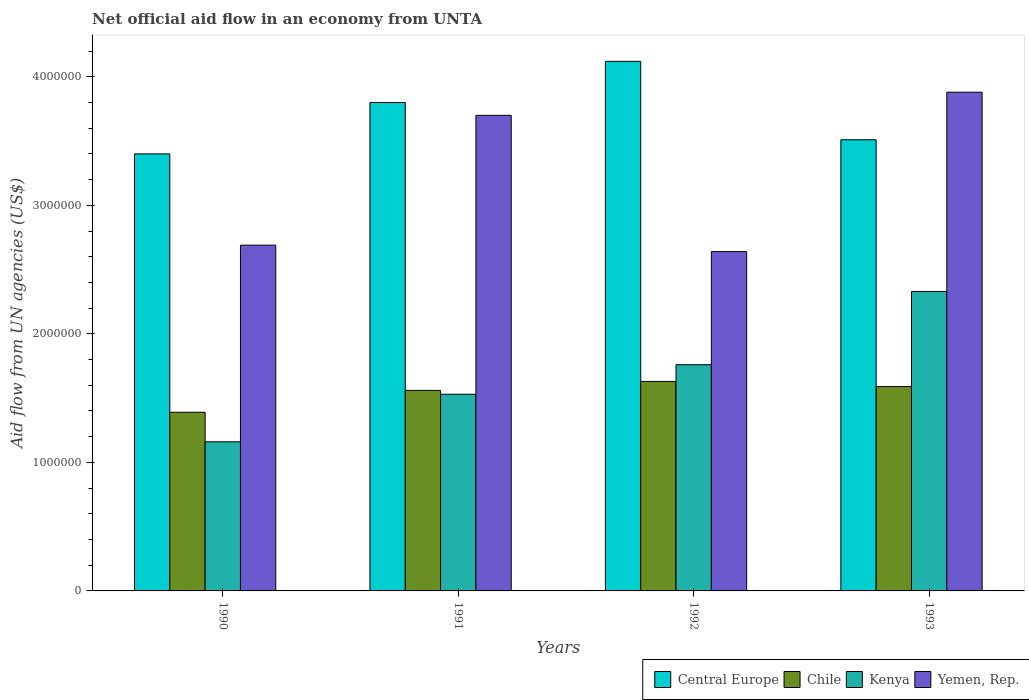How many groups of bars are there?
Make the answer very short. 4. Are the number of bars per tick equal to the number of legend labels?
Make the answer very short. Yes. How many bars are there on the 1st tick from the left?
Give a very brief answer. 4. What is the label of the 2nd group of bars from the left?
Your answer should be compact. 1991. In how many cases, is the number of bars for a given year not equal to the number of legend labels?
Provide a short and direct response. 0. What is the net official aid flow in Kenya in 1992?
Make the answer very short. 1.76e+06. Across all years, what is the maximum net official aid flow in Central Europe?
Provide a succinct answer. 4.12e+06. Across all years, what is the minimum net official aid flow in Kenya?
Your answer should be very brief. 1.16e+06. What is the total net official aid flow in Yemen, Rep. in the graph?
Ensure brevity in your answer.  1.29e+07. What is the difference between the net official aid flow in Chile in 1993 and the net official aid flow in Central Europe in 1990?
Ensure brevity in your answer.  -1.81e+06. What is the average net official aid flow in Yemen, Rep. per year?
Provide a short and direct response. 3.23e+06. In the year 1992, what is the difference between the net official aid flow in Yemen, Rep. and net official aid flow in Chile?
Your response must be concise. 1.01e+06. In how many years, is the net official aid flow in Kenya greater than 2800000 US$?
Give a very brief answer. 0. What is the ratio of the net official aid flow in Chile in 1990 to that in 1993?
Ensure brevity in your answer.  0.87. Is the net official aid flow in Central Europe in 1990 less than that in 1992?
Your answer should be compact. Yes. Is the difference between the net official aid flow in Yemen, Rep. in 1990 and 1993 greater than the difference between the net official aid flow in Chile in 1990 and 1993?
Provide a succinct answer. No. What is the difference between the highest and the second highest net official aid flow in Central Europe?
Provide a succinct answer. 3.20e+05. What is the difference between the highest and the lowest net official aid flow in Central Europe?
Provide a succinct answer. 7.20e+05. Is the sum of the net official aid flow in Chile in 1991 and 1993 greater than the maximum net official aid flow in Yemen, Rep. across all years?
Offer a terse response. No. Is it the case that in every year, the sum of the net official aid flow in Kenya and net official aid flow in Central Europe is greater than the sum of net official aid flow in Yemen, Rep. and net official aid flow in Chile?
Ensure brevity in your answer.  Yes. What does the 3rd bar from the left in 1993 represents?
Keep it short and to the point. Kenya. What does the 4th bar from the right in 1991 represents?
Your answer should be very brief. Central Europe. Are all the bars in the graph horizontal?
Your answer should be very brief. No. How many years are there in the graph?
Your answer should be compact. 4. What is the difference between two consecutive major ticks on the Y-axis?
Keep it short and to the point. 1.00e+06. Does the graph contain any zero values?
Give a very brief answer. No. Does the graph contain grids?
Your response must be concise. No. Where does the legend appear in the graph?
Ensure brevity in your answer.  Bottom right. What is the title of the graph?
Your answer should be compact. Net official aid flow in an economy from UNTA. What is the label or title of the Y-axis?
Offer a terse response. Aid flow from UN agencies (US$). What is the Aid flow from UN agencies (US$) in Central Europe in 1990?
Your response must be concise. 3.40e+06. What is the Aid flow from UN agencies (US$) of Chile in 1990?
Make the answer very short. 1.39e+06. What is the Aid flow from UN agencies (US$) of Kenya in 1990?
Make the answer very short. 1.16e+06. What is the Aid flow from UN agencies (US$) in Yemen, Rep. in 1990?
Your answer should be very brief. 2.69e+06. What is the Aid flow from UN agencies (US$) of Central Europe in 1991?
Provide a short and direct response. 3.80e+06. What is the Aid flow from UN agencies (US$) of Chile in 1991?
Your answer should be very brief. 1.56e+06. What is the Aid flow from UN agencies (US$) of Kenya in 1991?
Ensure brevity in your answer.  1.53e+06. What is the Aid flow from UN agencies (US$) in Yemen, Rep. in 1991?
Keep it short and to the point. 3.70e+06. What is the Aid flow from UN agencies (US$) in Central Europe in 1992?
Your answer should be compact. 4.12e+06. What is the Aid flow from UN agencies (US$) in Chile in 1992?
Your answer should be compact. 1.63e+06. What is the Aid flow from UN agencies (US$) of Kenya in 1992?
Keep it short and to the point. 1.76e+06. What is the Aid flow from UN agencies (US$) of Yemen, Rep. in 1992?
Your answer should be very brief. 2.64e+06. What is the Aid flow from UN agencies (US$) of Central Europe in 1993?
Ensure brevity in your answer.  3.51e+06. What is the Aid flow from UN agencies (US$) in Chile in 1993?
Your answer should be compact. 1.59e+06. What is the Aid flow from UN agencies (US$) of Kenya in 1993?
Make the answer very short. 2.33e+06. What is the Aid flow from UN agencies (US$) of Yemen, Rep. in 1993?
Provide a short and direct response. 3.88e+06. Across all years, what is the maximum Aid flow from UN agencies (US$) of Central Europe?
Offer a very short reply. 4.12e+06. Across all years, what is the maximum Aid flow from UN agencies (US$) of Chile?
Give a very brief answer. 1.63e+06. Across all years, what is the maximum Aid flow from UN agencies (US$) of Kenya?
Offer a terse response. 2.33e+06. Across all years, what is the maximum Aid flow from UN agencies (US$) in Yemen, Rep.?
Your answer should be very brief. 3.88e+06. Across all years, what is the minimum Aid flow from UN agencies (US$) in Central Europe?
Provide a succinct answer. 3.40e+06. Across all years, what is the minimum Aid flow from UN agencies (US$) of Chile?
Provide a succinct answer. 1.39e+06. Across all years, what is the minimum Aid flow from UN agencies (US$) in Kenya?
Your answer should be very brief. 1.16e+06. Across all years, what is the minimum Aid flow from UN agencies (US$) of Yemen, Rep.?
Provide a short and direct response. 2.64e+06. What is the total Aid flow from UN agencies (US$) in Central Europe in the graph?
Provide a short and direct response. 1.48e+07. What is the total Aid flow from UN agencies (US$) in Chile in the graph?
Make the answer very short. 6.17e+06. What is the total Aid flow from UN agencies (US$) of Kenya in the graph?
Keep it short and to the point. 6.78e+06. What is the total Aid flow from UN agencies (US$) in Yemen, Rep. in the graph?
Give a very brief answer. 1.29e+07. What is the difference between the Aid flow from UN agencies (US$) in Central Europe in 1990 and that in 1991?
Your response must be concise. -4.00e+05. What is the difference between the Aid flow from UN agencies (US$) of Kenya in 1990 and that in 1991?
Your response must be concise. -3.70e+05. What is the difference between the Aid flow from UN agencies (US$) in Yemen, Rep. in 1990 and that in 1991?
Keep it short and to the point. -1.01e+06. What is the difference between the Aid flow from UN agencies (US$) of Central Europe in 1990 and that in 1992?
Offer a terse response. -7.20e+05. What is the difference between the Aid flow from UN agencies (US$) in Kenya in 1990 and that in 1992?
Provide a short and direct response. -6.00e+05. What is the difference between the Aid flow from UN agencies (US$) of Yemen, Rep. in 1990 and that in 1992?
Your answer should be very brief. 5.00e+04. What is the difference between the Aid flow from UN agencies (US$) in Chile in 1990 and that in 1993?
Your answer should be very brief. -2.00e+05. What is the difference between the Aid flow from UN agencies (US$) in Kenya in 1990 and that in 1993?
Your answer should be very brief. -1.17e+06. What is the difference between the Aid flow from UN agencies (US$) of Yemen, Rep. in 1990 and that in 1993?
Provide a succinct answer. -1.19e+06. What is the difference between the Aid flow from UN agencies (US$) of Central Europe in 1991 and that in 1992?
Make the answer very short. -3.20e+05. What is the difference between the Aid flow from UN agencies (US$) in Yemen, Rep. in 1991 and that in 1992?
Provide a short and direct response. 1.06e+06. What is the difference between the Aid flow from UN agencies (US$) in Central Europe in 1991 and that in 1993?
Ensure brevity in your answer.  2.90e+05. What is the difference between the Aid flow from UN agencies (US$) of Kenya in 1991 and that in 1993?
Make the answer very short. -8.00e+05. What is the difference between the Aid flow from UN agencies (US$) in Central Europe in 1992 and that in 1993?
Ensure brevity in your answer.  6.10e+05. What is the difference between the Aid flow from UN agencies (US$) in Kenya in 1992 and that in 1993?
Keep it short and to the point. -5.70e+05. What is the difference between the Aid flow from UN agencies (US$) in Yemen, Rep. in 1992 and that in 1993?
Your answer should be compact. -1.24e+06. What is the difference between the Aid flow from UN agencies (US$) in Central Europe in 1990 and the Aid flow from UN agencies (US$) in Chile in 1991?
Offer a terse response. 1.84e+06. What is the difference between the Aid flow from UN agencies (US$) in Central Europe in 1990 and the Aid flow from UN agencies (US$) in Kenya in 1991?
Ensure brevity in your answer.  1.87e+06. What is the difference between the Aid flow from UN agencies (US$) in Chile in 1990 and the Aid flow from UN agencies (US$) in Yemen, Rep. in 1991?
Offer a terse response. -2.31e+06. What is the difference between the Aid flow from UN agencies (US$) in Kenya in 1990 and the Aid flow from UN agencies (US$) in Yemen, Rep. in 1991?
Your response must be concise. -2.54e+06. What is the difference between the Aid flow from UN agencies (US$) of Central Europe in 1990 and the Aid flow from UN agencies (US$) of Chile in 1992?
Offer a very short reply. 1.77e+06. What is the difference between the Aid flow from UN agencies (US$) in Central Europe in 1990 and the Aid flow from UN agencies (US$) in Kenya in 1992?
Provide a succinct answer. 1.64e+06. What is the difference between the Aid flow from UN agencies (US$) in Central Europe in 1990 and the Aid flow from UN agencies (US$) in Yemen, Rep. in 1992?
Offer a very short reply. 7.60e+05. What is the difference between the Aid flow from UN agencies (US$) of Chile in 1990 and the Aid flow from UN agencies (US$) of Kenya in 1992?
Provide a succinct answer. -3.70e+05. What is the difference between the Aid flow from UN agencies (US$) of Chile in 1990 and the Aid flow from UN agencies (US$) of Yemen, Rep. in 1992?
Your answer should be very brief. -1.25e+06. What is the difference between the Aid flow from UN agencies (US$) in Kenya in 1990 and the Aid flow from UN agencies (US$) in Yemen, Rep. in 1992?
Keep it short and to the point. -1.48e+06. What is the difference between the Aid flow from UN agencies (US$) in Central Europe in 1990 and the Aid flow from UN agencies (US$) in Chile in 1993?
Your response must be concise. 1.81e+06. What is the difference between the Aid flow from UN agencies (US$) in Central Europe in 1990 and the Aid flow from UN agencies (US$) in Kenya in 1993?
Ensure brevity in your answer.  1.07e+06. What is the difference between the Aid flow from UN agencies (US$) of Central Europe in 1990 and the Aid flow from UN agencies (US$) of Yemen, Rep. in 1993?
Provide a succinct answer. -4.80e+05. What is the difference between the Aid flow from UN agencies (US$) in Chile in 1990 and the Aid flow from UN agencies (US$) in Kenya in 1993?
Provide a short and direct response. -9.40e+05. What is the difference between the Aid flow from UN agencies (US$) in Chile in 1990 and the Aid flow from UN agencies (US$) in Yemen, Rep. in 1993?
Keep it short and to the point. -2.49e+06. What is the difference between the Aid flow from UN agencies (US$) in Kenya in 1990 and the Aid flow from UN agencies (US$) in Yemen, Rep. in 1993?
Keep it short and to the point. -2.72e+06. What is the difference between the Aid flow from UN agencies (US$) in Central Europe in 1991 and the Aid flow from UN agencies (US$) in Chile in 1992?
Provide a short and direct response. 2.17e+06. What is the difference between the Aid flow from UN agencies (US$) in Central Europe in 1991 and the Aid flow from UN agencies (US$) in Kenya in 1992?
Your response must be concise. 2.04e+06. What is the difference between the Aid flow from UN agencies (US$) of Central Europe in 1991 and the Aid flow from UN agencies (US$) of Yemen, Rep. in 1992?
Offer a terse response. 1.16e+06. What is the difference between the Aid flow from UN agencies (US$) of Chile in 1991 and the Aid flow from UN agencies (US$) of Kenya in 1992?
Your answer should be very brief. -2.00e+05. What is the difference between the Aid flow from UN agencies (US$) of Chile in 1991 and the Aid flow from UN agencies (US$) of Yemen, Rep. in 1992?
Your answer should be very brief. -1.08e+06. What is the difference between the Aid flow from UN agencies (US$) in Kenya in 1991 and the Aid flow from UN agencies (US$) in Yemen, Rep. in 1992?
Your answer should be compact. -1.11e+06. What is the difference between the Aid flow from UN agencies (US$) of Central Europe in 1991 and the Aid flow from UN agencies (US$) of Chile in 1993?
Provide a succinct answer. 2.21e+06. What is the difference between the Aid flow from UN agencies (US$) of Central Europe in 1991 and the Aid flow from UN agencies (US$) of Kenya in 1993?
Offer a terse response. 1.47e+06. What is the difference between the Aid flow from UN agencies (US$) of Central Europe in 1991 and the Aid flow from UN agencies (US$) of Yemen, Rep. in 1993?
Make the answer very short. -8.00e+04. What is the difference between the Aid flow from UN agencies (US$) in Chile in 1991 and the Aid flow from UN agencies (US$) in Kenya in 1993?
Offer a very short reply. -7.70e+05. What is the difference between the Aid flow from UN agencies (US$) of Chile in 1991 and the Aid flow from UN agencies (US$) of Yemen, Rep. in 1993?
Your answer should be compact. -2.32e+06. What is the difference between the Aid flow from UN agencies (US$) of Kenya in 1991 and the Aid flow from UN agencies (US$) of Yemen, Rep. in 1993?
Provide a short and direct response. -2.35e+06. What is the difference between the Aid flow from UN agencies (US$) of Central Europe in 1992 and the Aid flow from UN agencies (US$) of Chile in 1993?
Provide a succinct answer. 2.53e+06. What is the difference between the Aid flow from UN agencies (US$) in Central Europe in 1992 and the Aid flow from UN agencies (US$) in Kenya in 1993?
Your answer should be very brief. 1.79e+06. What is the difference between the Aid flow from UN agencies (US$) in Central Europe in 1992 and the Aid flow from UN agencies (US$) in Yemen, Rep. in 1993?
Provide a short and direct response. 2.40e+05. What is the difference between the Aid flow from UN agencies (US$) of Chile in 1992 and the Aid flow from UN agencies (US$) of Kenya in 1993?
Your response must be concise. -7.00e+05. What is the difference between the Aid flow from UN agencies (US$) of Chile in 1992 and the Aid flow from UN agencies (US$) of Yemen, Rep. in 1993?
Keep it short and to the point. -2.25e+06. What is the difference between the Aid flow from UN agencies (US$) in Kenya in 1992 and the Aid flow from UN agencies (US$) in Yemen, Rep. in 1993?
Your answer should be compact. -2.12e+06. What is the average Aid flow from UN agencies (US$) of Central Europe per year?
Your response must be concise. 3.71e+06. What is the average Aid flow from UN agencies (US$) in Chile per year?
Ensure brevity in your answer.  1.54e+06. What is the average Aid flow from UN agencies (US$) in Kenya per year?
Ensure brevity in your answer.  1.70e+06. What is the average Aid flow from UN agencies (US$) of Yemen, Rep. per year?
Provide a short and direct response. 3.23e+06. In the year 1990, what is the difference between the Aid flow from UN agencies (US$) of Central Europe and Aid flow from UN agencies (US$) of Chile?
Ensure brevity in your answer.  2.01e+06. In the year 1990, what is the difference between the Aid flow from UN agencies (US$) in Central Europe and Aid flow from UN agencies (US$) in Kenya?
Your answer should be very brief. 2.24e+06. In the year 1990, what is the difference between the Aid flow from UN agencies (US$) in Central Europe and Aid flow from UN agencies (US$) in Yemen, Rep.?
Provide a short and direct response. 7.10e+05. In the year 1990, what is the difference between the Aid flow from UN agencies (US$) of Chile and Aid flow from UN agencies (US$) of Kenya?
Ensure brevity in your answer.  2.30e+05. In the year 1990, what is the difference between the Aid flow from UN agencies (US$) of Chile and Aid flow from UN agencies (US$) of Yemen, Rep.?
Offer a terse response. -1.30e+06. In the year 1990, what is the difference between the Aid flow from UN agencies (US$) of Kenya and Aid flow from UN agencies (US$) of Yemen, Rep.?
Give a very brief answer. -1.53e+06. In the year 1991, what is the difference between the Aid flow from UN agencies (US$) of Central Europe and Aid flow from UN agencies (US$) of Chile?
Provide a succinct answer. 2.24e+06. In the year 1991, what is the difference between the Aid flow from UN agencies (US$) in Central Europe and Aid flow from UN agencies (US$) in Kenya?
Your answer should be compact. 2.27e+06. In the year 1991, what is the difference between the Aid flow from UN agencies (US$) in Central Europe and Aid flow from UN agencies (US$) in Yemen, Rep.?
Offer a terse response. 1.00e+05. In the year 1991, what is the difference between the Aid flow from UN agencies (US$) in Chile and Aid flow from UN agencies (US$) in Yemen, Rep.?
Ensure brevity in your answer.  -2.14e+06. In the year 1991, what is the difference between the Aid flow from UN agencies (US$) of Kenya and Aid flow from UN agencies (US$) of Yemen, Rep.?
Offer a terse response. -2.17e+06. In the year 1992, what is the difference between the Aid flow from UN agencies (US$) of Central Europe and Aid flow from UN agencies (US$) of Chile?
Offer a very short reply. 2.49e+06. In the year 1992, what is the difference between the Aid flow from UN agencies (US$) of Central Europe and Aid flow from UN agencies (US$) of Kenya?
Your answer should be very brief. 2.36e+06. In the year 1992, what is the difference between the Aid flow from UN agencies (US$) in Central Europe and Aid flow from UN agencies (US$) in Yemen, Rep.?
Keep it short and to the point. 1.48e+06. In the year 1992, what is the difference between the Aid flow from UN agencies (US$) in Chile and Aid flow from UN agencies (US$) in Kenya?
Your response must be concise. -1.30e+05. In the year 1992, what is the difference between the Aid flow from UN agencies (US$) in Chile and Aid flow from UN agencies (US$) in Yemen, Rep.?
Your answer should be very brief. -1.01e+06. In the year 1992, what is the difference between the Aid flow from UN agencies (US$) of Kenya and Aid flow from UN agencies (US$) of Yemen, Rep.?
Offer a very short reply. -8.80e+05. In the year 1993, what is the difference between the Aid flow from UN agencies (US$) of Central Europe and Aid flow from UN agencies (US$) of Chile?
Provide a succinct answer. 1.92e+06. In the year 1993, what is the difference between the Aid flow from UN agencies (US$) in Central Europe and Aid flow from UN agencies (US$) in Kenya?
Give a very brief answer. 1.18e+06. In the year 1993, what is the difference between the Aid flow from UN agencies (US$) of Central Europe and Aid flow from UN agencies (US$) of Yemen, Rep.?
Make the answer very short. -3.70e+05. In the year 1993, what is the difference between the Aid flow from UN agencies (US$) in Chile and Aid flow from UN agencies (US$) in Kenya?
Your answer should be compact. -7.40e+05. In the year 1993, what is the difference between the Aid flow from UN agencies (US$) of Chile and Aid flow from UN agencies (US$) of Yemen, Rep.?
Provide a succinct answer. -2.29e+06. In the year 1993, what is the difference between the Aid flow from UN agencies (US$) of Kenya and Aid flow from UN agencies (US$) of Yemen, Rep.?
Ensure brevity in your answer.  -1.55e+06. What is the ratio of the Aid flow from UN agencies (US$) of Central Europe in 1990 to that in 1991?
Keep it short and to the point. 0.89. What is the ratio of the Aid flow from UN agencies (US$) in Chile in 1990 to that in 1991?
Make the answer very short. 0.89. What is the ratio of the Aid flow from UN agencies (US$) of Kenya in 1990 to that in 1991?
Offer a terse response. 0.76. What is the ratio of the Aid flow from UN agencies (US$) in Yemen, Rep. in 1990 to that in 1991?
Your answer should be compact. 0.73. What is the ratio of the Aid flow from UN agencies (US$) in Central Europe in 1990 to that in 1992?
Keep it short and to the point. 0.83. What is the ratio of the Aid flow from UN agencies (US$) of Chile in 1990 to that in 1992?
Offer a terse response. 0.85. What is the ratio of the Aid flow from UN agencies (US$) of Kenya in 1990 to that in 1992?
Provide a succinct answer. 0.66. What is the ratio of the Aid flow from UN agencies (US$) in Yemen, Rep. in 1990 to that in 1992?
Provide a short and direct response. 1.02. What is the ratio of the Aid flow from UN agencies (US$) in Central Europe in 1990 to that in 1993?
Offer a very short reply. 0.97. What is the ratio of the Aid flow from UN agencies (US$) of Chile in 1990 to that in 1993?
Your response must be concise. 0.87. What is the ratio of the Aid flow from UN agencies (US$) in Kenya in 1990 to that in 1993?
Make the answer very short. 0.5. What is the ratio of the Aid flow from UN agencies (US$) of Yemen, Rep. in 1990 to that in 1993?
Offer a very short reply. 0.69. What is the ratio of the Aid flow from UN agencies (US$) in Central Europe in 1991 to that in 1992?
Your answer should be compact. 0.92. What is the ratio of the Aid flow from UN agencies (US$) in Chile in 1991 to that in 1992?
Ensure brevity in your answer.  0.96. What is the ratio of the Aid flow from UN agencies (US$) in Kenya in 1991 to that in 1992?
Keep it short and to the point. 0.87. What is the ratio of the Aid flow from UN agencies (US$) in Yemen, Rep. in 1991 to that in 1992?
Your answer should be very brief. 1.4. What is the ratio of the Aid flow from UN agencies (US$) in Central Europe in 1991 to that in 1993?
Provide a succinct answer. 1.08. What is the ratio of the Aid flow from UN agencies (US$) of Chile in 1991 to that in 1993?
Keep it short and to the point. 0.98. What is the ratio of the Aid flow from UN agencies (US$) in Kenya in 1991 to that in 1993?
Provide a short and direct response. 0.66. What is the ratio of the Aid flow from UN agencies (US$) of Yemen, Rep. in 1991 to that in 1993?
Your response must be concise. 0.95. What is the ratio of the Aid flow from UN agencies (US$) in Central Europe in 1992 to that in 1993?
Provide a succinct answer. 1.17. What is the ratio of the Aid flow from UN agencies (US$) of Chile in 1992 to that in 1993?
Ensure brevity in your answer.  1.03. What is the ratio of the Aid flow from UN agencies (US$) of Kenya in 1992 to that in 1993?
Give a very brief answer. 0.76. What is the ratio of the Aid flow from UN agencies (US$) in Yemen, Rep. in 1992 to that in 1993?
Give a very brief answer. 0.68. What is the difference between the highest and the second highest Aid flow from UN agencies (US$) in Chile?
Your answer should be very brief. 4.00e+04. What is the difference between the highest and the second highest Aid flow from UN agencies (US$) of Kenya?
Ensure brevity in your answer.  5.70e+05. What is the difference between the highest and the second highest Aid flow from UN agencies (US$) in Yemen, Rep.?
Offer a terse response. 1.80e+05. What is the difference between the highest and the lowest Aid flow from UN agencies (US$) in Central Europe?
Make the answer very short. 7.20e+05. What is the difference between the highest and the lowest Aid flow from UN agencies (US$) in Chile?
Ensure brevity in your answer.  2.40e+05. What is the difference between the highest and the lowest Aid flow from UN agencies (US$) of Kenya?
Your answer should be compact. 1.17e+06. What is the difference between the highest and the lowest Aid flow from UN agencies (US$) of Yemen, Rep.?
Your answer should be compact. 1.24e+06. 